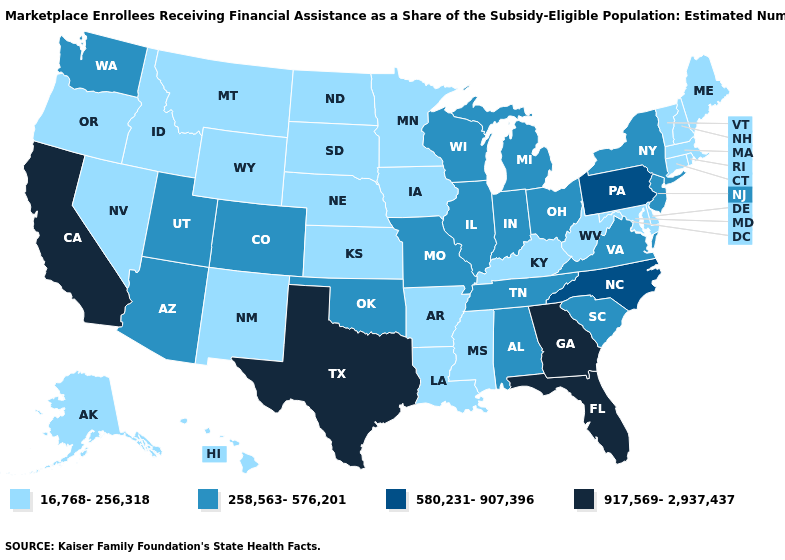What is the lowest value in the MidWest?
Be succinct. 16,768-256,318. What is the value of Maine?
Quick response, please. 16,768-256,318. What is the lowest value in the West?
Write a very short answer. 16,768-256,318. Name the states that have a value in the range 580,231-907,396?
Give a very brief answer. North Carolina, Pennsylvania. Does the first symbol in the legend represent the smallest category?
Be succinct. Yes. Does Nebraska have the lowest value in the MidWest?
Be succinct. Yes. Name the states that have a value in the range 917,569-2,937,437?
Be succinct. California, Florida, Georgia, Texas. Name the states that have a value in the range 16,768-256,318?
Give a very brief answer. Alaska, Arkansas, Connecticut, Delaware, Hawaii, Idaho, Iowa, Kansas, Kentucky, Louisiana, Maine, Maryland, Massachusetts, Minnesota, Mississippi, Montana, Nebraska, Nevada, New Hampshire, New Mexico, North Dakota, Oregon, Rhode Island, South Dakota, Vermont, West Virginia, Wyoming. Name the states that have a value in the range 16,768-256,318?
Concise answer only. Alaska, Arkansas, Connecticut, Delaware, Hawaii, Idaho, Iowa, Kansas, Kentucky, Louisiana, Maine, Maryland, Massachusetts, Minnesota, Mississippi, Montana, Nebraska, Nevada, New Hampshire, New Mexico, North Dakota, Oregon, Rhode Island, South Dakota, Vermont, West Virginia, Wyoming. Name the states that have a value in the range 16,768-256,318?
Give a very brief answer. Alaska, Arkansas, Connecticut, Delaware, Hawaii, Idaho, Iowa, Kansas, Kentucky, Louisiana, Maine, Maryland, Massachusetts, Minnesota, Mississippi, Montana, Nebraska, Nevada, New Hampshire, New Mexico, North Dakota, Oregon, Rhode Island, South Dakota, Vermont, West Virginia, Wyoming. Does the map have missing data?
Answer briefly. No. Does Maryland have a lower value than New Hampshire?
Answer briefly. No. Which states have the lowest value in the MidWest?
Be succinct. Iowa, Kansas, Minnesota, Nebraska, North Dakota, South Dakota. 